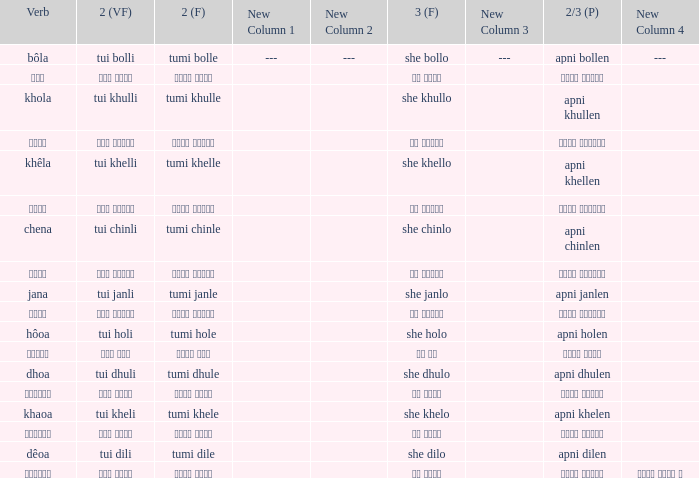What is the 2(vf) for তুমি বললে? তুই বললি. 